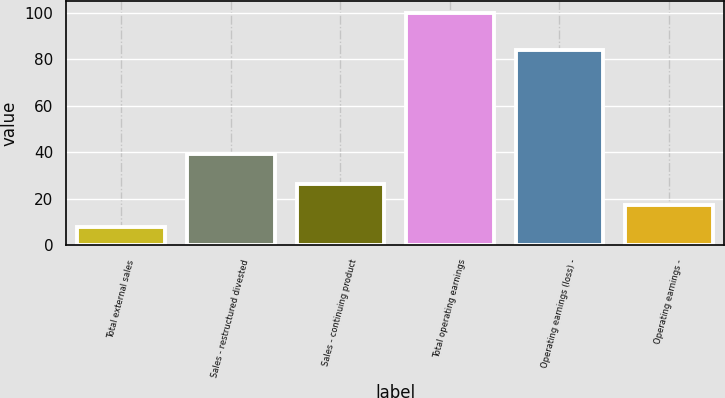Convert chart. <chart><loc_0><loc_0><loc_500><loc_500><bar_chart><fcel>Total external sales<fcel>Sales - restructured divested<fcel>Sales - continuing product<fcel>Total operating earnings<fcel>Operating earnings (loss) -<fcel>Operating earnings -<nl><fcel>8<fcel>39<fcel>26.4<fcel>100<fcel>84<fcel>17.2<nl></chart> 